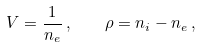<formula> <loc_0><loc_0><loc_500><loc_500>V = \frac { 1 } { n _ { e } } \, , \quad \rho = n _ { i } - n _ { e } \, ,</formula> 